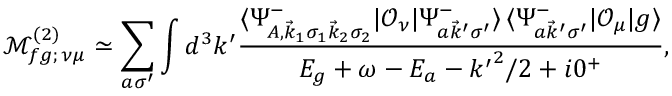<formula> <loc_0><loc_0><loc_500><loc_500>\mathcal { M } _ { f g ; \, \nu \mu } ^ { ( 2 ) } \simeq \sum _ { a \sigma ^ { \prime } } \int d ^ { 3 } k ^ { \prime } \frac { \langle \Psi _ { A , \vec { k } _ { 1 } \sigma _ { 1 } \vec { k } _ { 2 } \sigma _ { 2 } } ^ { - } | \mathcal { O } _ { \nu } | \Psi _ { a \vec { k } ^ { \prime } \sigma ^ { \prime } } ^ { - } \rangle \, \langle \Psi _ { a \vec { k } ^ { \prime } \sigma ^ { \prime } } ^ { - } | \mathcal { O } _ { \mu } | g \rangle } { E _ { g } + \omega - E _ { a } - { k ^ { \prime } } ^ { 2 } / 2 + i 0 ^ { + } } ,</formula> 